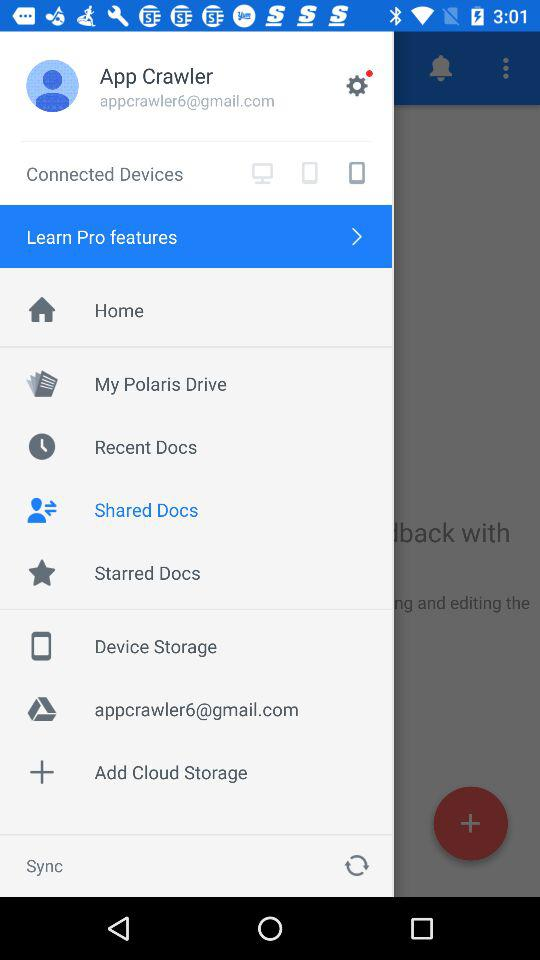With what email address is their Google drive associated? The email address is appcrawler6@gmail.com. 